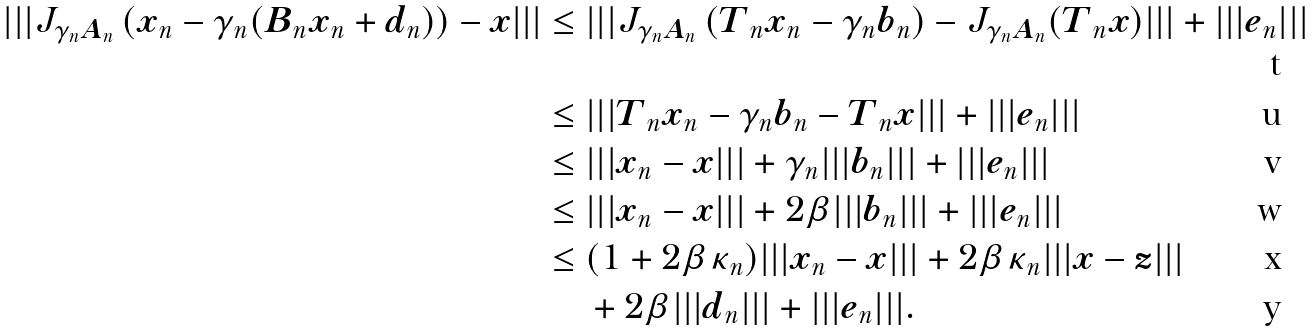Convert formula to latex. <formula><loc_0><loc_0><loc_500><loc_500>| | | J _ { \gamma _ { n } { \boldsymbol A } _ { n } } \left ( { \boldsymbol x } _ { n } - \gamma _ { n } ( { \boldsymbol B } _ { n } { \boldsymbol x } _ { n } + { \boldsymbol d } _ { n } ) \right ) - { \boldsymbol x } | | | & \leq | | | J _ { \gamma _ { n } { \boldsymbol A } _ { n } } \left ( { \boldsymbol T } _ { n } { \boldsymbol x } _ { n } - \gamma _ { n } { \boldsymbol b } _ { n } \right ) - J _ { \gamma _ { n } { \boldsymbol A } _ { n } } ( { \boldsymbol T } _ { n } { \boldsymbol x } ) | | | + | | | { \boldsymbol e } _ { n } | | | \\ & \leq | | | { \boldsymbol T } _ { n } { \boldsymbol x } _ { n } - \gamma _ { n } { \boldsymbol b } _ { n } - { \boldsymbol T } _ { n } { \boldsymbol x } | | | + | | | { \boldsymbol e } _ { n } | | | \\ & \leq | | | { \boldsymbol x } _ { n } - { \boldsymbol x } | | | + \gamma _ { n } | | | { \boldsymbol b } _ { n } | | | + | | | { \boldsymbol e } _ { n } | | | \\ & \leq | | | { \boldsymbol x } _ { n } - { \boldsymbol x } | | | + 2 \beta | | | { \boldsymbol b } _ { n } | | | + | | | { \boldsymbol e } _ { n } | | | \\ & \leq ( 1 + 2 \beta \kappa _ { n } ) | | | { \boldsymbol x } _ { n } - { \boldsymbol x } | | | + 2 \beta \kappa _ { n } | | | { \boldsymbol x } - { \boldsymbol z } | | | \\ & \quad \, + 2 \beta | | | { \boldsymbol d } _ { n } | | | + | | | { \boldsymbol e } _ { n } | | | .</formula> 